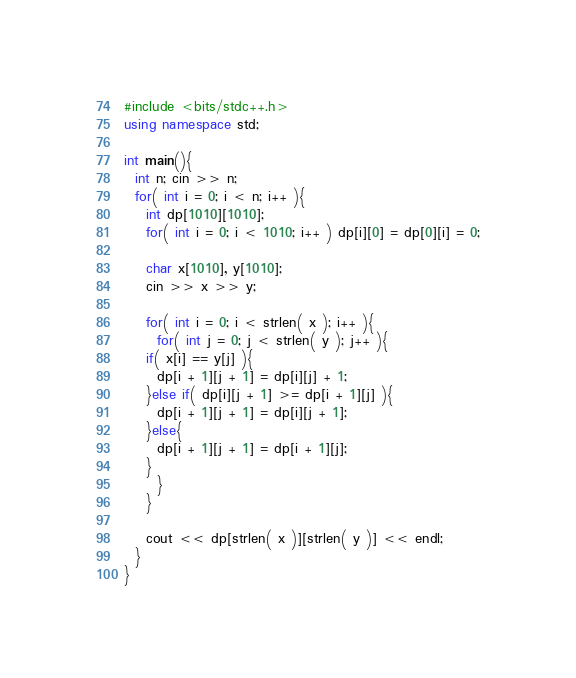Convert code to text. <code><loc_0><loc_0><loc_500><loc_500><_C++_>#include <bits/stdc++.h>
using namespace std;

int main(){
  int n; cin >> n;
  for( int i = 0; i < n; i++ ){
    int dp[1010][1010];
    for( int i = 0; i < 1010; i++ ) dp[i][0] = dp[0][i] = 0;
    
    char x[1010], y[1010];
    cin >> x >> y;

    for( int i = 0; i < strlen( x ); i++ ){
      for( int j = 0; j < strlen( y ); j++ ){
	if( x[i] == y[j] ){
	  dp[i + 1][j + 1] = dp[i][j] + 1; 
	}else if( dp[i][j + 1] >= dp[i + 1][j] ){
	  dp[i + 1][j + 1] = dp[i][j + 1];
	}else{
	  dp[i + 1][j + 1] = dp[i + 1][j];
	}
      }
    }

    cout << dp[strlen( x )][strlen( y )] << endl;
  }
}

</code> 